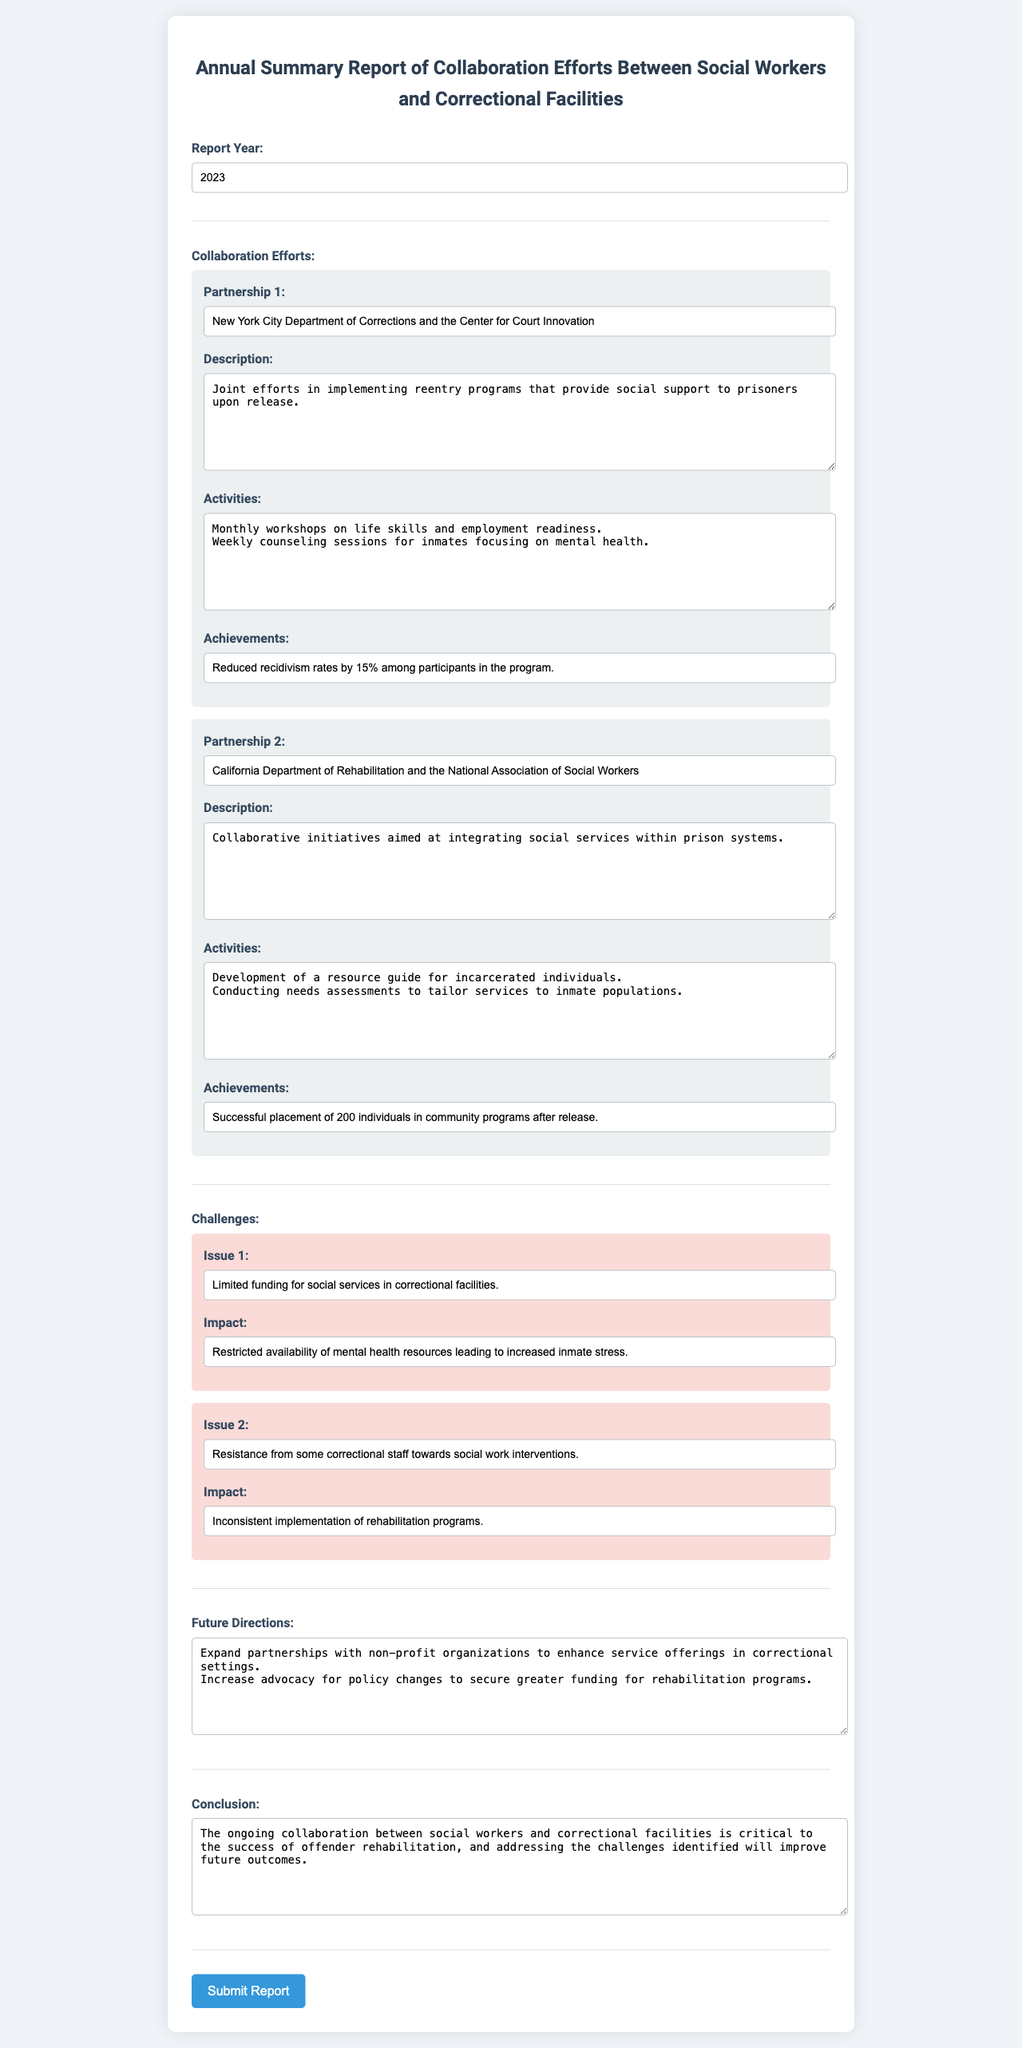What was the report year? The report year is specified in the document under the 'Report Year' section.
Answer: 2023 Who partnered with the New York City Department of Corrections? The partnership details are provided in the Collaboration Efforts section relating to the New York City Department of Corrections.
Answer: Center for Court Innovation What achievement was noted for Partnership 1? The achievements for each partnership are mentioned in their respective sections; Partnership 1's achievements are listed clearly.
Answer: Reduced recidivism rates by 15% among participants in the program What is the first challenge listed in the document? The challenges faced are detailed under the Challenges section, specifically the first issue identified.
Answer: Limited funding for social services in correctional facilities What was the impact of resistance from correctional staff? The impact of the identified issues is also described in the Challenges section, specifically related to the resistance to social work interventions.
Answer: Inconsistent implementation of rehabilitation programs What future direction is suggested in the document? The future directions provided are summarized in a specific section of the document to guide improvements.
Answer: Expand partnerships with non-profit organizations to enhance service offerings in correctional settings 